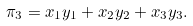Convert formula to latex. <formula><loc_0><loc_0><loc_500><loc_500>\pi _ { 3 } = x _ { 1 } y _ { 1 } + x _ { 2 } y _ { 2 } + x _ { 3 } y _ { 3 } .</formula> 